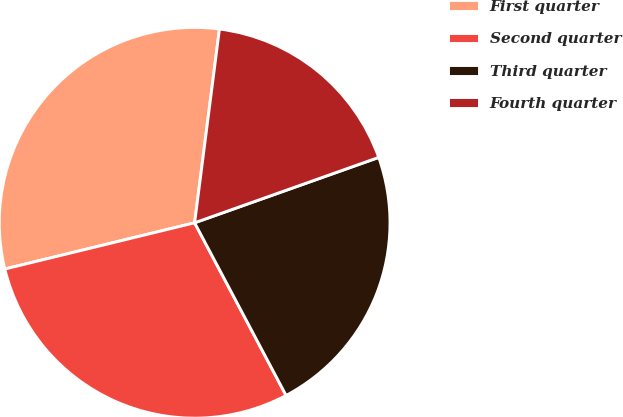Convert chart to OTSL. <chart><loc_0><loc_0><loc_500><loc_500><pie_chart><fcel>First quarter<fcel>Second quarter<fcel>Third quarter<fcel>Fourth quarter<nl><fcel>30.83%<fcel>28.95%<fcel>22.68%<fcel>17.54%<nl></chart> 